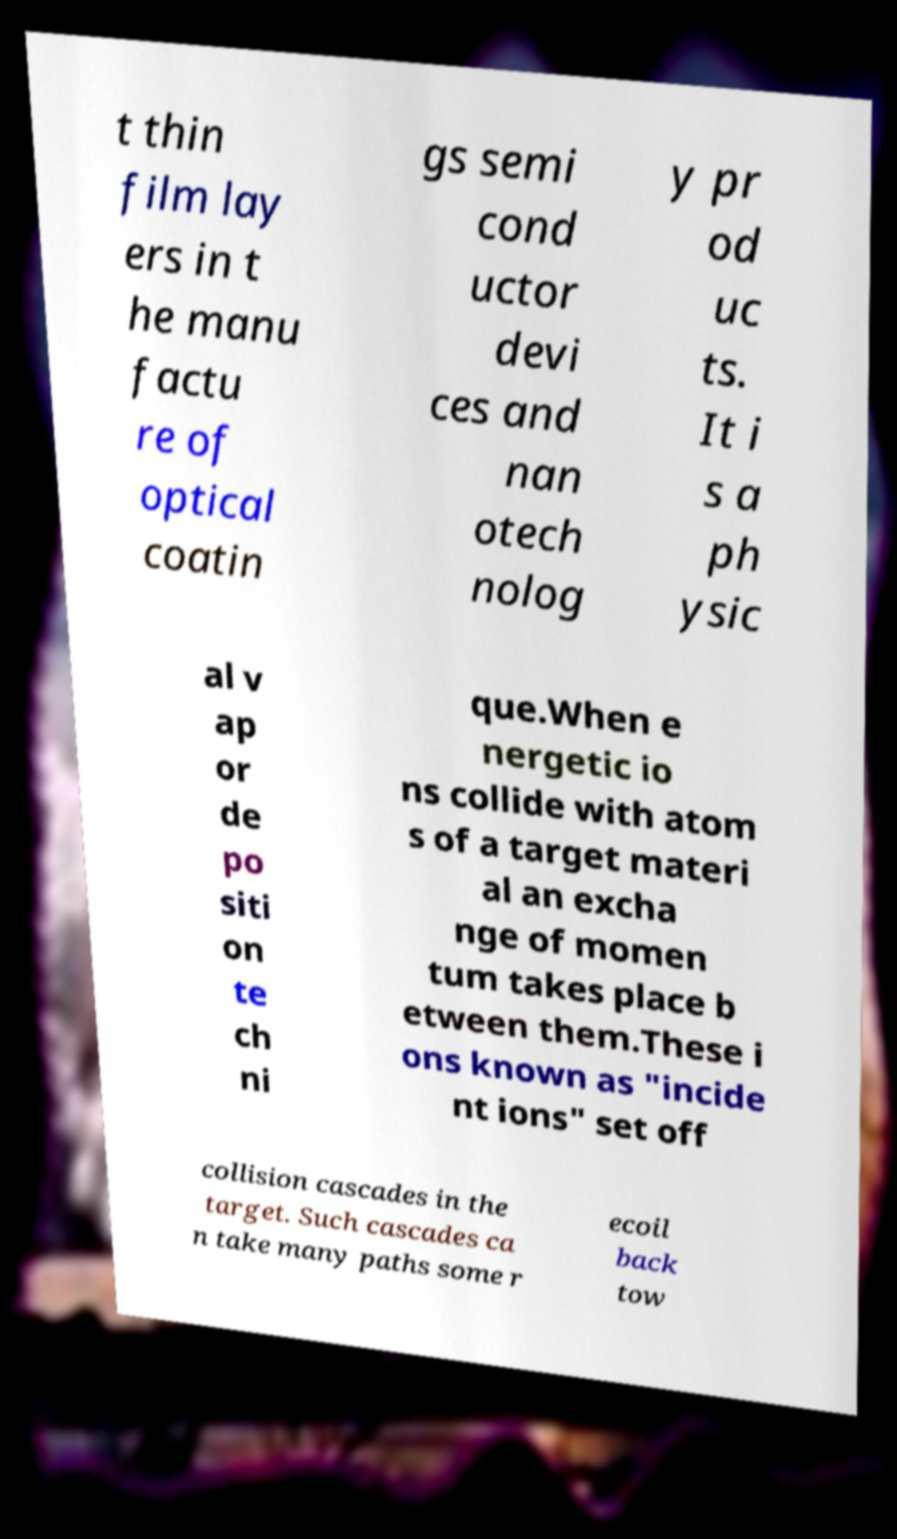For documentation purposes, I need the text within this image transcribed. Could you provide that? t thin film lay ers in t he manu factu re of optical coatin gs semi cond uctor devi ces and nan otech nolog y pr od uc ts. It i s a ph ysic al v ap or de po siti on te ch ni que.When e nergetic io ns collide with atom s of a target materi al an excha nge of momen tum takes place b etween them.These i ons known as "incide nt ions" set off collision cascades in the target. Such cascades ca n take many paths some r ecoil back tow 